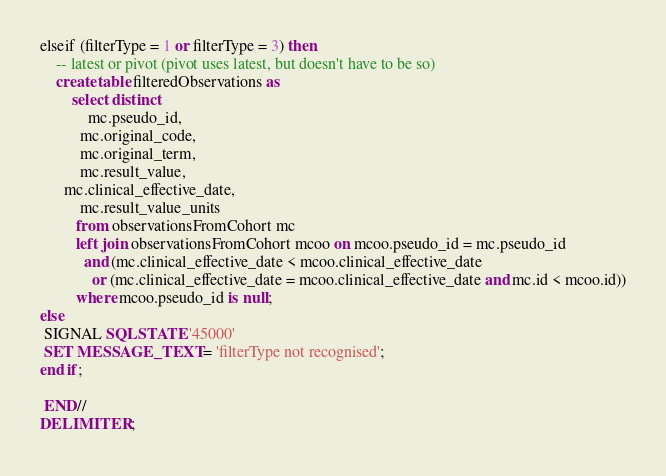<code> <loc_0><loc_0><loc_500><loc_500><_SQL_>elseif (filterType = 1 or filterType = 3) then
	-- latest or pivot (pivot uses latest, but doesn't have to be so)
	create table filteredObservations as
		select distinct
			mc.pseudo_id,
		  mc.original_code,
		  mc.original_term,
		  mc.result_value,
      mc.clinical_effective_date,
		  mc.result_value_units
		 from observationsFromCohort mc
		 left join observationsFromCohort mcoo on mcoo.pseudo_id = mc.pseudo_id
		   and (mc.clinical_effective_date < mcoo.clinical_effective_date
			 or (mc.clinical_effective_date = mcoo.clinical_effective_date and mc.id < mcoo.id))
		 where mcoo.pseudo_id is null;
else
 SIGNAL SQLSTATE '45000'
 SET MESSAGE_TEXT = 'filterType not recognised';
end if;

 END//
DELIMITER ;
</code> 